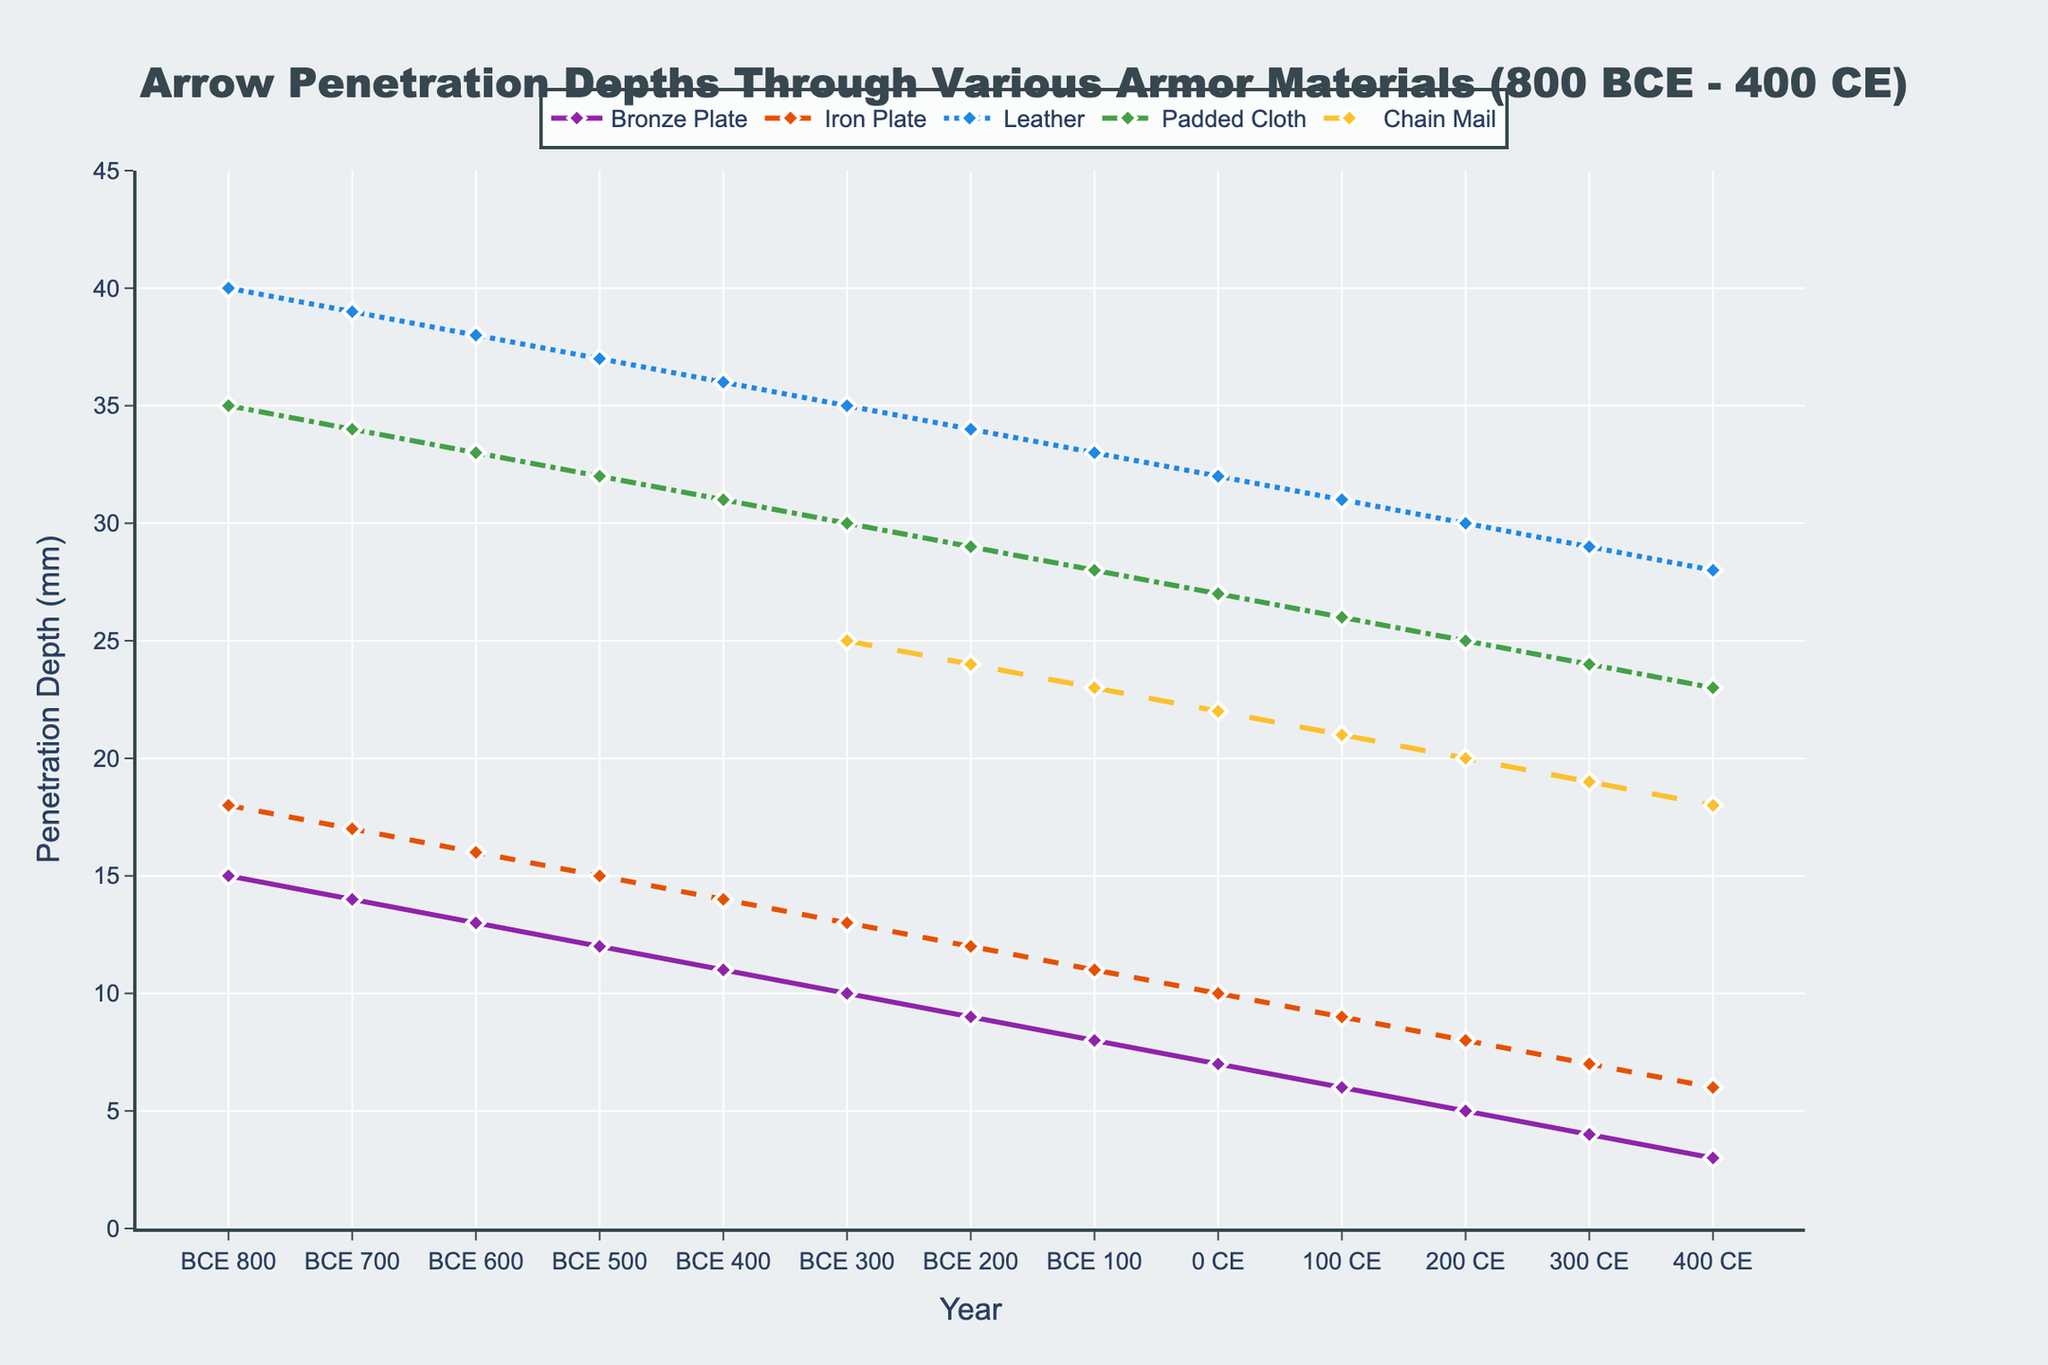Which armor material shows the largest reduction in arrow penetration depth over the recorded period? To determine the largest reduction, calculate the difference between the earliest and latest penetration depths for each material. For Bronze Plate, it's 15 - 3 = 12 mm; for Iron Plate, it's 18 - 6 = 12 mm; for Leather, it's 40 - 28 = 12 mm; for Padded Cloth, it's 35 - 23 = 12 mm; and for Chain Mail (introduced later), it's 25 - 18 = 7 mm. Hence, Bronze Plate, Iron Plate, Leather, and Padded Cloth show the largest reduction.
Answer: Bronze Plate, Iron Plate, Leather, and Padded Cloth When did Chain Mail first appear in the data and what was its corresponding penetration depth? By observing the legend and the x-axis, Chain Mail first appears at 300 BCE with a penetration depth of 25 mm.
Answer: 300 BCE, 25 mm Which material had the least penetration depth in 200 CE and what was that depth? Compare the penetration depths of all materials in 200 CE. Bronze Plate had 5 mm, Iron Plate had 8 mm, Leather had 30 mm, Padded Cloth had 25 mm, and Chain Mail had 20 mm. The least penetration depth was for Bronze Plate with 5 mm.
Answer: Bronze Plate, 5 mm What is the trend of penetration depth through Iron Plate from 800 BCE to 400 CE? Identify the trend by observing the line for Iron Plate. The penetration depth decreases steadily from 18 mm in 800 BCE to 6 mm in 400 CE.
Answer: Steady decrease Between 100 BCE and 100 CE, which armor material showed the largest absolute decrease in penetration depth? Calculate the decrease for each material between 100 BCE and 100 CE. Bronze Plate: 8 - 6 = 2 mm; Iron Plate: 11 - 9 = 2 mm; Leather: 33 - 31 = 2 mm; Padded Cloth: 28 - 26 = 2 mm; Chain Mail: not applicable due to introduction. Since all show a 2 mm decrease, they equally had the largest absolute decrease.
Answer: Bronze Plate, Iron Plate, Leather, and Padded Cloth How does the penetration depth of Padded Cloth in 0 CE compare to Iron Plate in the same year? Observing the lines for Padded Cloth and Iron Plate at 0 CE, Padded Cloth's penetration depth is 27 mm while Iron Plate's is 10 mm. Padded Cloth has a greater penetration depth than Iron Plate.
Answer: Padded Cloth has greater penetration depth What is the average penetration depth of Leather armor in 200 CE and 400 CE? Calculate the average by adding the penetration depths in 200 CE (30 mm) and 400 CE (28 mm) and then dividing by 2. The average is (30 + 28)/2 = 29 mm.
Answer: 29 mm 